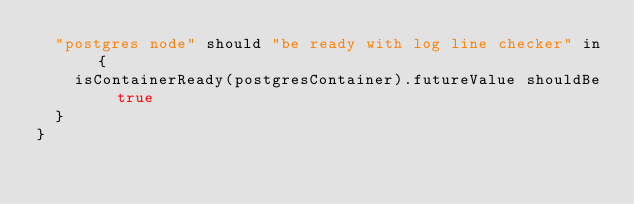Convert code to text. <code><loc_0><loc_0><loc_500><loc_500><_Scala_>  "postgres node" should "be ready with log line checker" in {
    isContainerReady(postgresContainer).futureValue shouldBe true
  }
}
</code> 